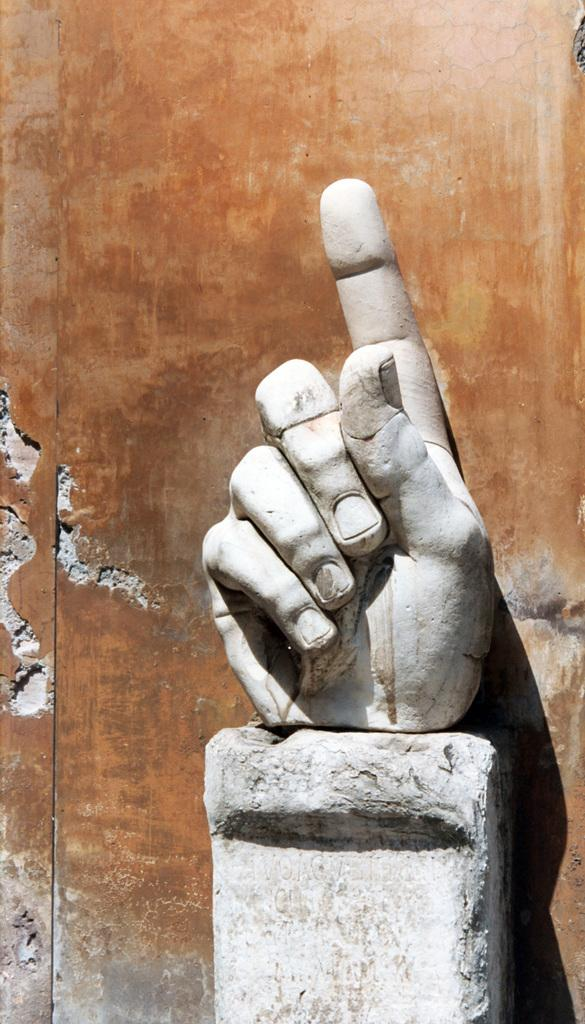What is the main subject of the picture? The main subject of the picture is a sculpture of a hand. What color is the sculpture? The sculpture is white in color. What can be seen in the background of the picture? There is a wall in the background of the picture. What type of butter is being used to create the texture of the jeans in the image? There is no butter or jeans present in the image; it features a white sculpture of a hand and a wall in the background. 